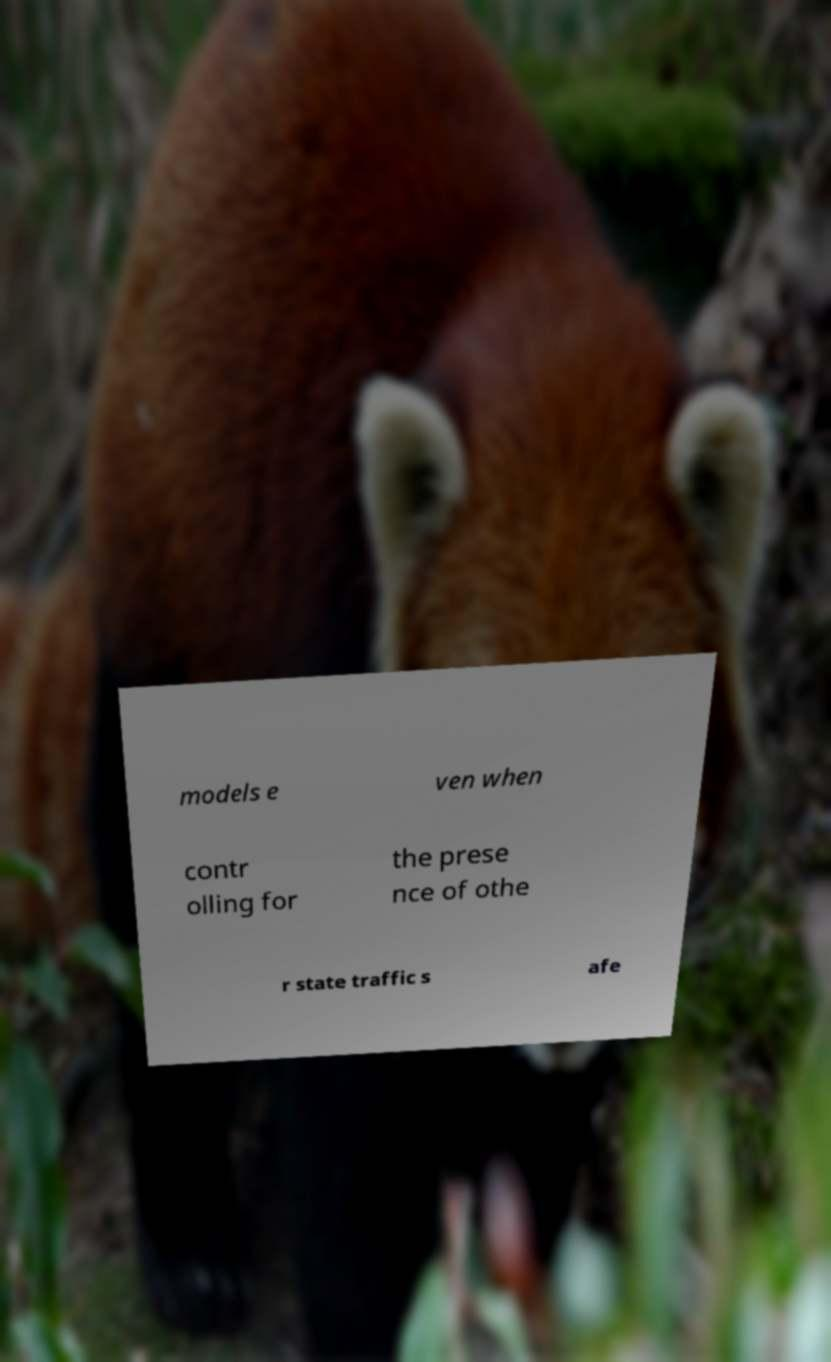There's text embedded in this image that I need extracted. Can you transcribe it verbatim? models e ven when contr olling for the prese nce of othe r state traffic s afe 